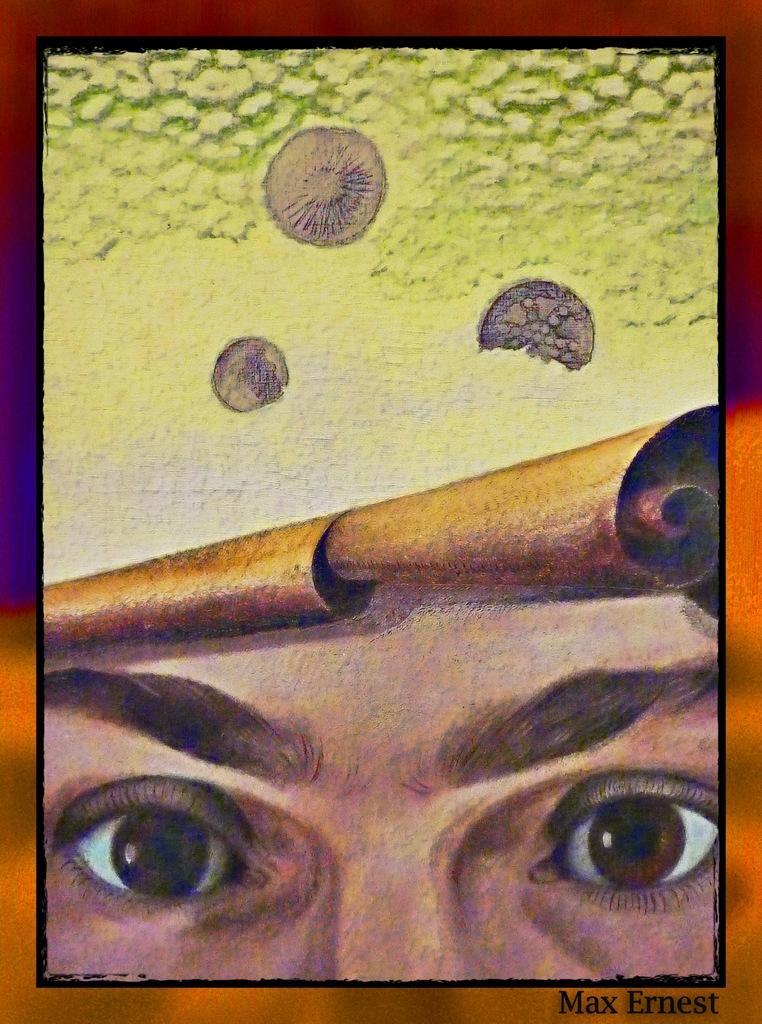Could you give a brief overview of what you see in this image? In this image we can see the painting. And at the bottom we can see some text. And we can see the eyes in the painting. 